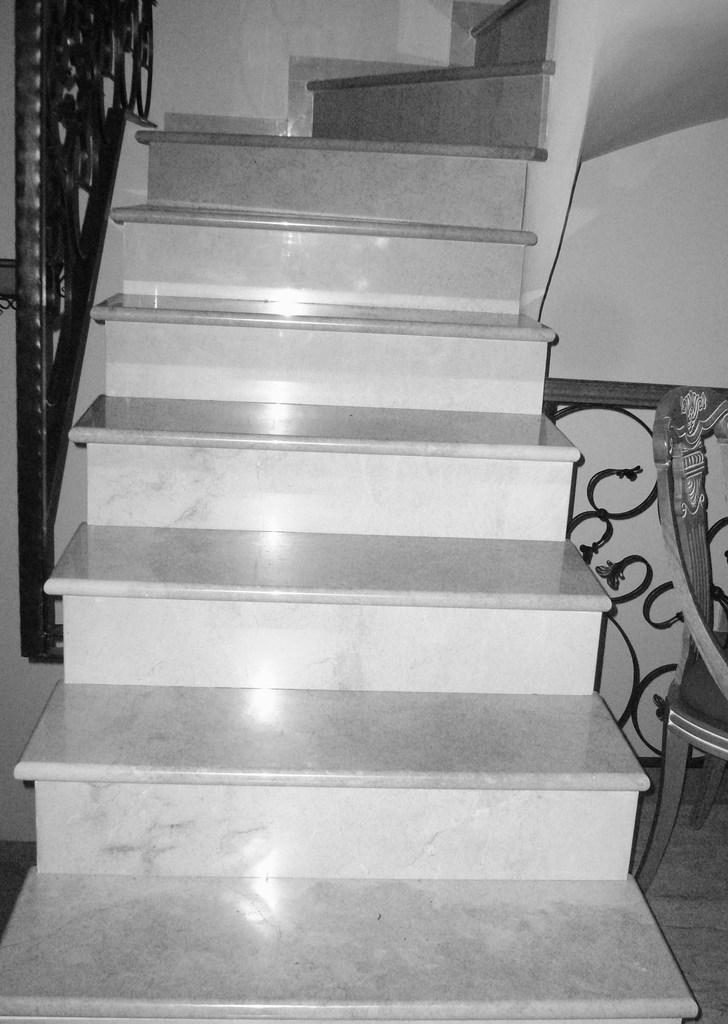What can be seen in the foreground of the image? There are stairs in the foreground of the image. What is located on the right side of the image? There is a chair on the right side of the image. What is on the left side of the image? There is a fence on the left side of the image. How many fingers can be seen on the body in the image? There is no body or fingers present in the image; it features stairs, a chair, and a fence. 